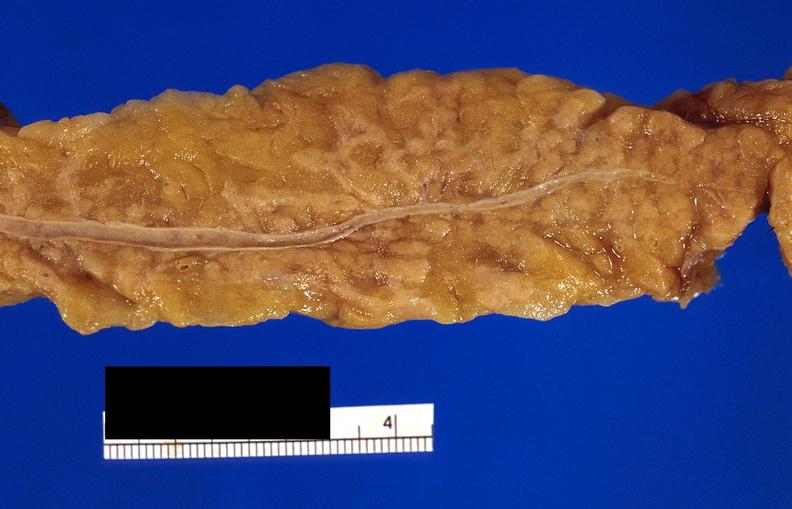does fixed tissue show pancreatic fat necrosis?
Answer the question using a single word or phrase. No 